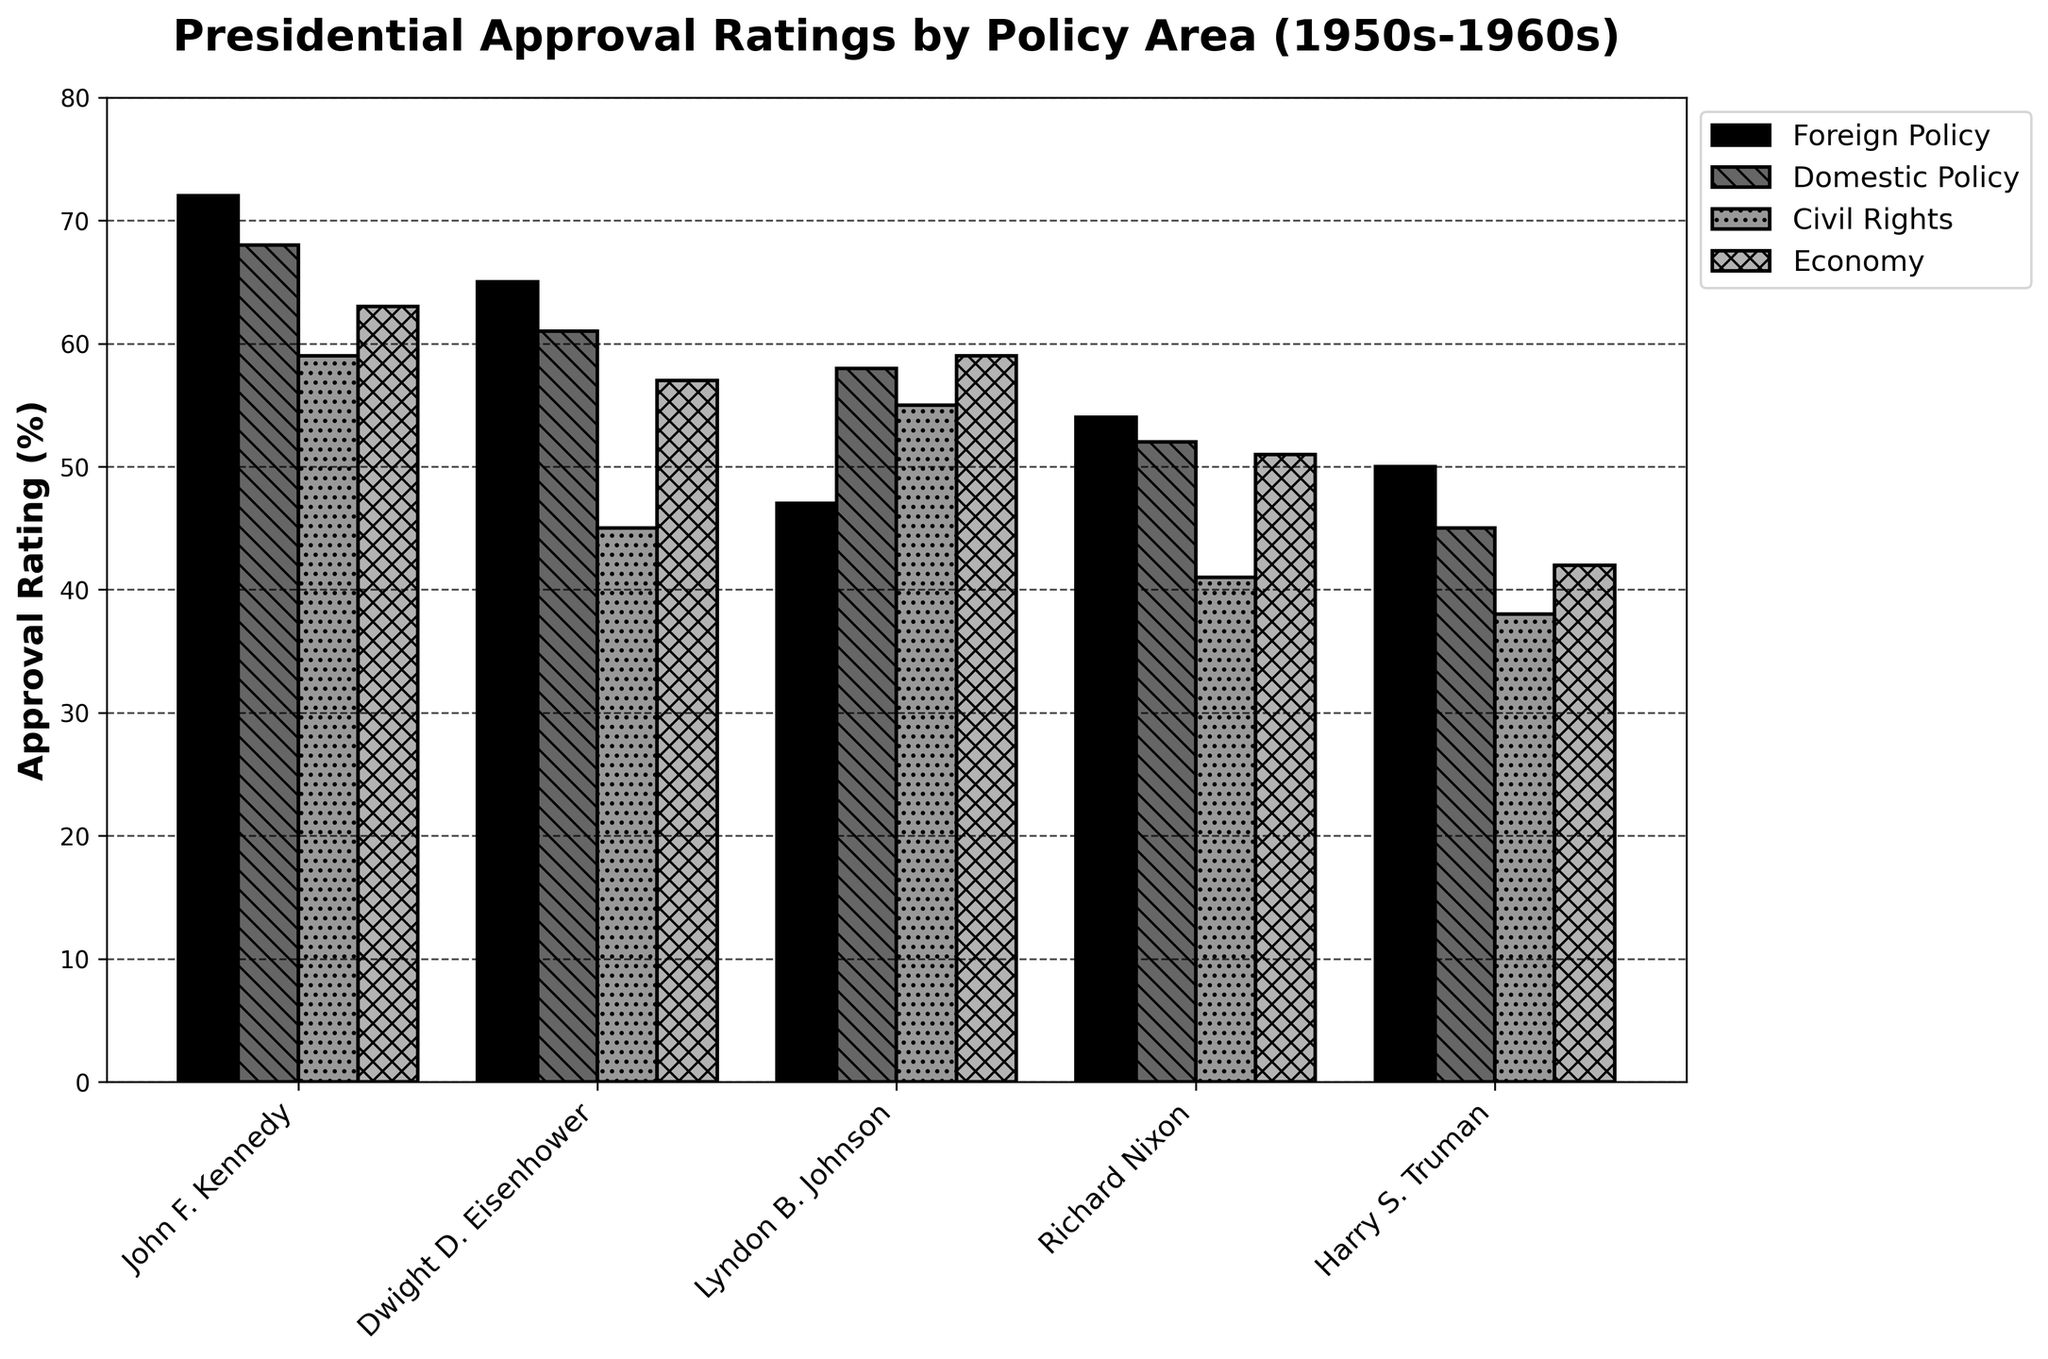Which president has the highest approval rating in Foreign Policy? The bar representing John's approval rating in Foreign Policy is the highest among all presidents in the chart.
Answer: John F. Kennedy What is the difference between Kennedy's and Eisenhower's approval ratings in Civil Rights? Kennedy's Civil Rights approval rating is 59%, while Eisenhower's is 45%. The difference is 59 - 45.
Answer: 14% What is the average approval rating of Nixon across all policy areas? Add all of Nixon's approval ratings: 54 (Foreign Policy) + 52 (Domestic Policy) + 41 (Civil Rights) + 51 (Economy). Then divide by the number of areas: (54 + 52 + 41 + 51) / 4.
Answer: 49.5% Who has the lowest approval rating for the Economy, and what is that rating? The shortest bar in the Economy category corresponds to Truman. His rating is 42%.
Answer: Harry S. Truman, 42% Is Johnson’s Domestic Policy approval rating higher or lower than Eisenhower’s? Look at the Domestic Policy bars for Johnson and Eisenhower. Johnson's rating is 58%, and Eisenhower's is 61%.
Answer: Lower Which president has the second-highest approval rating in Domestic Policy? The Domestic Policy bars show that Kennedy is highest (68%), Eisenhower is second (61%).
Answer: Dwight D. Eisenhower What is the combined approval rating of Truman in Domestic Policy and Economy? Add Truman's Domestic Policy approval rating (45%) and Economy (42%): 45 + 42.
Answer: 87% How much higher is Kennedy's approval rating in Foreign Policy compared to Nixon's? Kennedy's Foreign Policy rating is 72%, and Nixon's is 54%. The difference is 72 - 54.
Answer: 18% Which policy area did Kennedy receive the lowest approval rating, and what is that rating? Among Kennedy's bars, the Civil Rights approval rating is the lowest at 59%.
Answer: Civil Rights, 59% Place the presidents in order from highest total approval rating to lowest. Sum up the approval ratings for each president: Kennedy (72+68+59+63 = 262), Eisenhower (65+61+45+57 = 228), Johnson (47+58+55+59 = 219), Nixon (54+52+41+51 = 198), Truman (50+45+38+42 = 175).
Answer: Kennedy > Eisenhower > Johnson > Nixon > Truman 